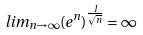<formula> <loc_0><loc_0><loc_500><loc_500>l i m _ { n \rightarrow \infty } ( e ^ { n } ) ^ { \frac { 1 } { \sqrt { n } } } = \infty</formula> 